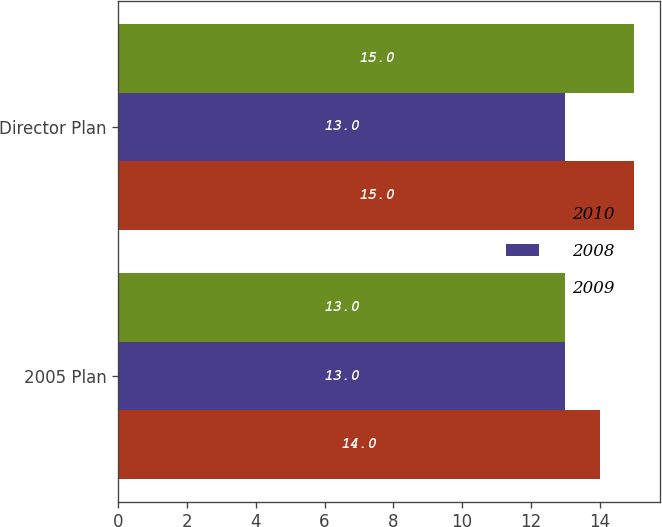Convert chart to OTSL. <chart><loc_0><loc_0><loc_500><loc_500><stacked_bar_chart><ecel><fcel>2005 Plan<fcel>Director Plan<nl><fcel>2010<fcel>14<fcel>15<nl><fcel>2008<fcel>13<fcel>13<nl><fcel>2009<fcel>13<fcel>15<nl></chart> 